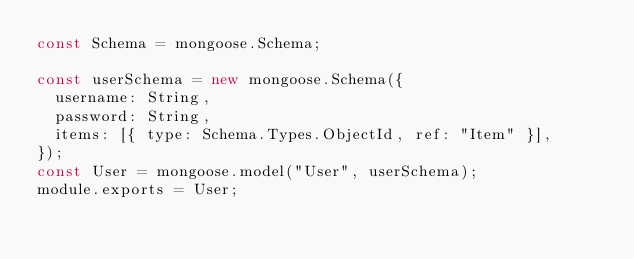Convert code to text. <code><loc_0><loc_0><loc_500><loc_500><_JavaScript_>const Schema = mongoose.Schema;

const userSchema = new mongoose.Schema({
  username: String,
  password: String,
  items: [{ type: Schema.Types.ObjectId, ref: "Item" }],
});
const User = mongoose.model("User", userSchema);
module.exports = User;
</code> 